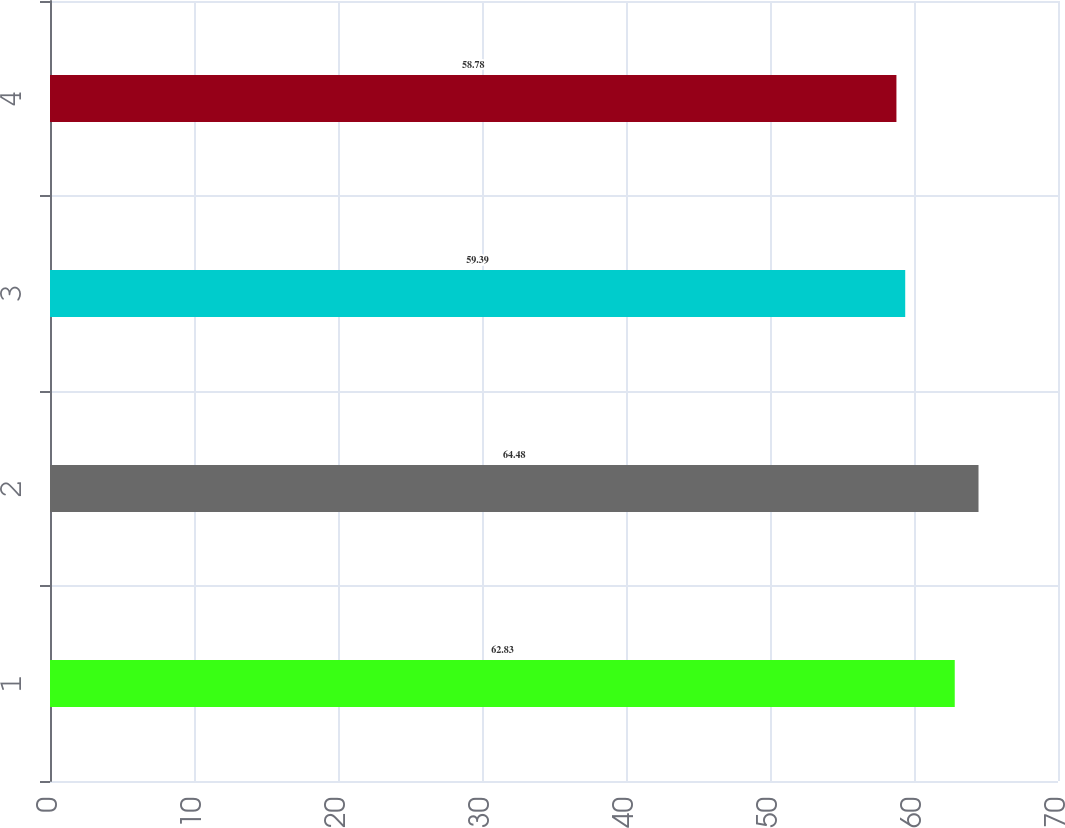Convert chart. <chart><loc_0><loc_0><loc_500><loc_500><bar_chart><fcel>1<fcel>2<fcel>3<fcel>4<nl><fcel>62.83<fcel>64.48<fcel>59.39<fcel>58.78<nl></chart> 